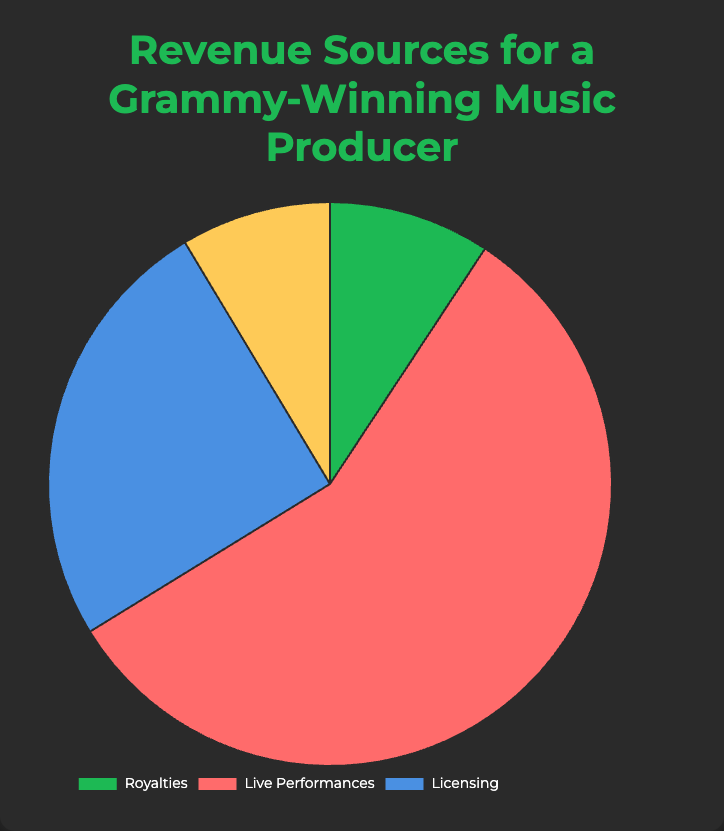What percentage of the total revenue comes from Licensing? To find the percentage, sum up the total revenue from all sources, then sum the revenue from Licensing, and divide the Licensing revenue by the total revenue. Multiply by 100 for the percentage. Total revenue is $1500000 + $1950000 + $950000 + $325000 = $4725000. Licensing revenue is $300000 + $200000 + $150000 + $250000 + $50000 = $950000. The percentage is ($950000 / $4725000) * 100 = 20.1%
Answer: 20.1% Which revenue source contributes the most to the total revenue? Simply look for the largest slice of the pie chart. The largest slice corresponds to Live Performances. Adding up individually, Live Performances’ total is $500000 + $300000 + $450000 + $700000 + $200000 = $2150000.
Answer: Live Performances What is the difference in revenue between Live Performances and Royalties? First, sum the revenues for Live Performances and Royalties. Live Performances total is $2150000, and Royalties total is $150000 + $100000 + $50000 + $20000 + $30000 = $350000. The difference is $2150000 - $350000 = $1800000.
Answer: $1800000 What portion of the revenue is represented by Merchandise? Find the total revenue, then the revenue from Merchandise. Merchandise revenue is $100000 + $75000 + $50000 + $40000 + $60000 = $325000. The total revenue is $4725000. The portion is ($325000 / $4725000) = 0.0688, or 6.88%.
Answer: 6.88% Which entity contributes the most within the Royalties category? Sum up the revenues for entities within Royalties and identify the largest. Spotify $150000, Apple Music $100000, Amazon Music $50000, Pandora $20000, YouTube $30000. The largest is Spotify.
Answer: Spotify Is the revenue from the Super Bowl Halftime Show greater than the entire Merchandise category? The Super Bowl Halftime Show brings $700000, and the entire Merchandise revenue is $325000. Since $700000 is greater than $325000, the answer is yes.
Answer: Yes Among all the entities listed, which single entity generates the highest revenue? Individually add up each entity's revenue across all categories and find the highest. The Super Bowl Halftime Show contributes $700000, which is the highest individual amount.
Answer: Super Bowl Halftime Show How much more revenue does the film score for Marvel Studios generate compared to the documentary background score for National Geographic? The revenue from the Marvel Studios score is $300000, and from National Geographic is $50000. The difference is $300000 - $50000 = $250000.
Answer: $250000 What is the average revenue per entity within the Merchandise category? Sum up the revenues for each entity within Merchandise and divide by the total number of entities. The total revenue is $325000 and there are 5 entities, so the average is $325000 / 5 = $65000.
Answer: $65000 